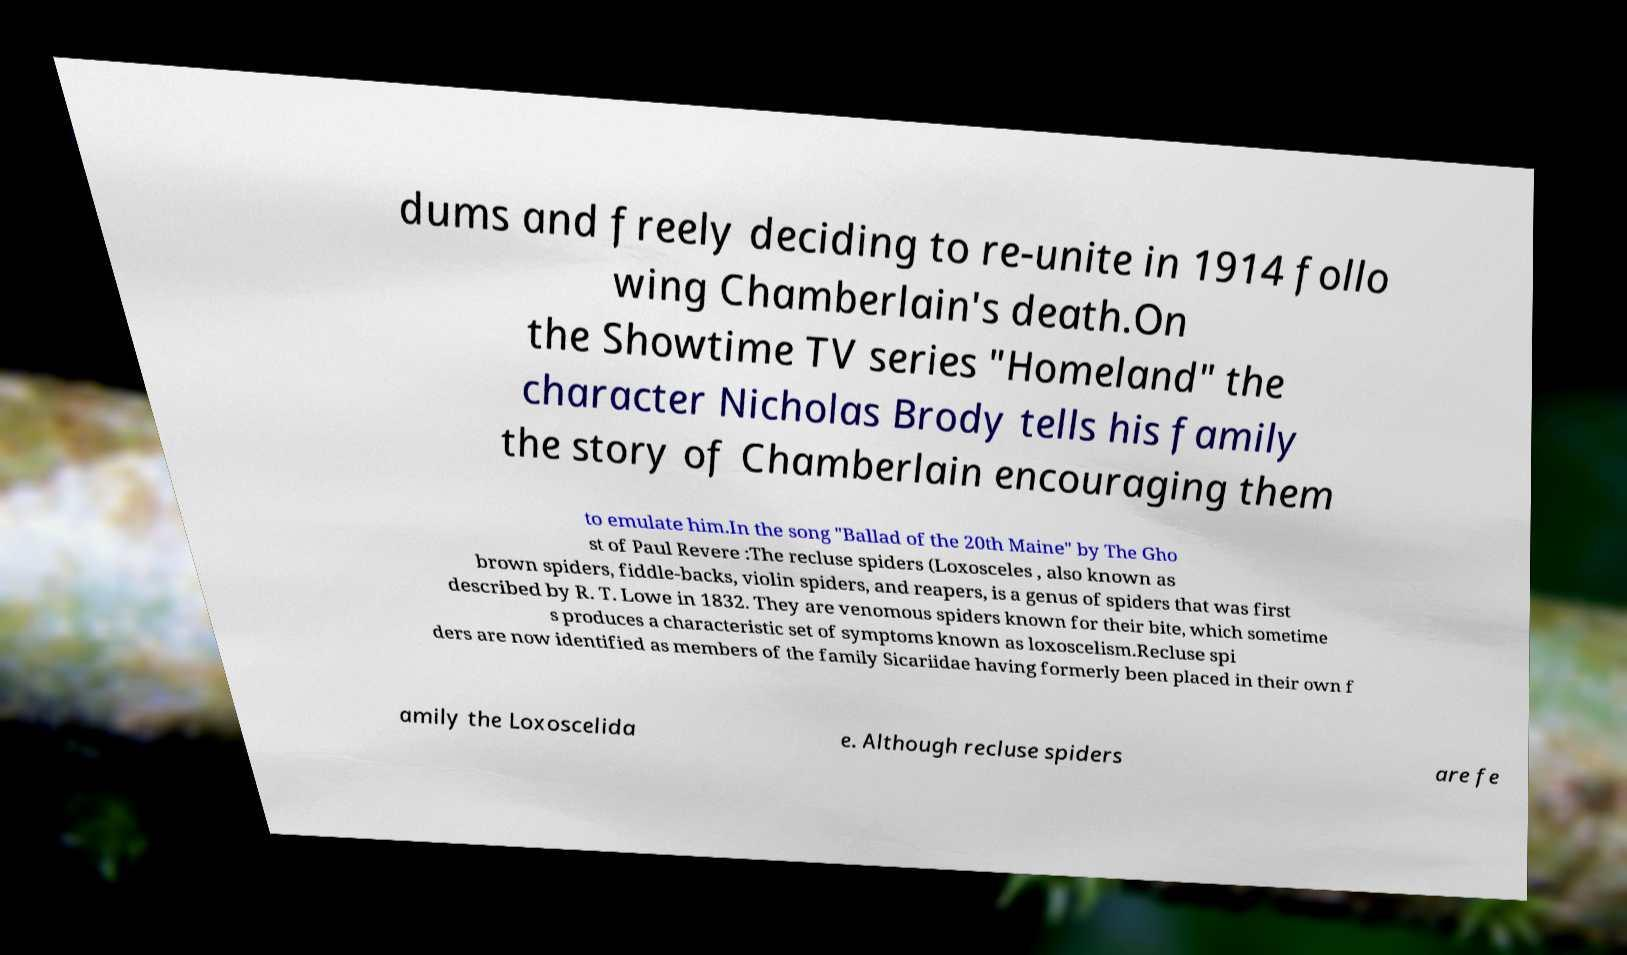Can you accurately transcribe the text from the provided image for me? dums and freely deciding to re-unite in 1914 follo wing Chamberlain's death.On the Showtime TV series "Homeland" the character Nicholas Brody tells his family the story of Chamberlain encouraging them to emulate him.In the song "Ballad of the 20th Maine" by The Gho st of Paul Revere :The recluse spiders (Loxosceles , also known as brown spiders, fiddle-backs, violin spiders, and reapers, is a genus of spiders that was first described by R. T. Lowe in 1832. They are venomous spiders known for their bite, which sometime s produces a characteristic set of symptoms known as loxoscelism.Recluse spi ders are now identified as members of the family Sicariidae having formerly been placed in their own f amily the Loxoscelida e. Although recluse spiders are fe 